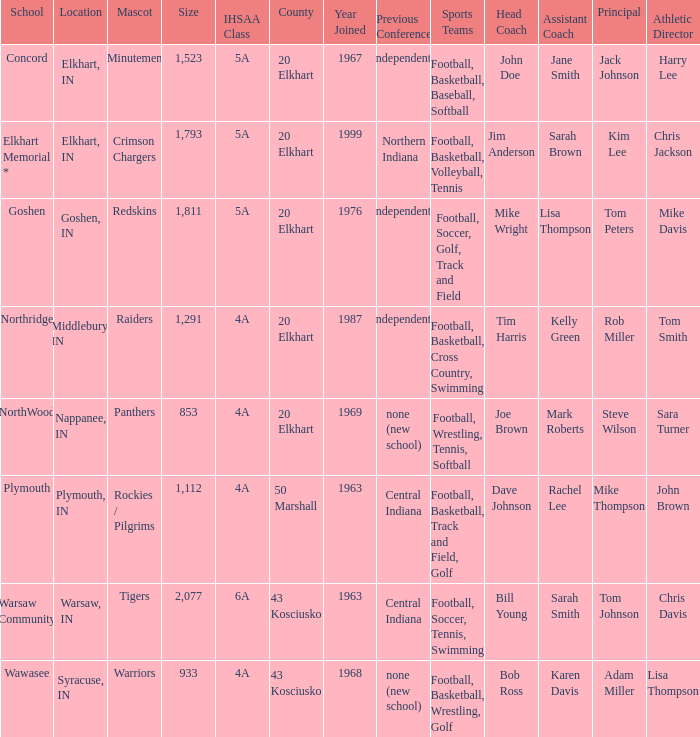In which country, with a size over 1,112 and an ihssa class of 5a, did membership occur before 1976? 20 Elkhart. 